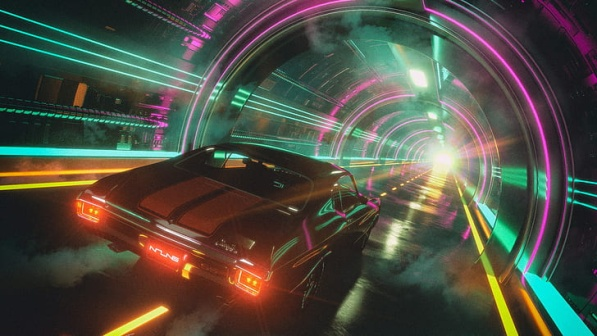Let's say the tunnel connects two different worlds. What could be the differences between these worlds? In this imaginative scenario, the tunnel could connect two vastly different worlds. On one side of the tunnel, we could have a world resembling our present day, with its challenges, limitations, and familiar landscapes. This world might be characterized by regular architecture, conventional vehicles, and a pragmatic way of life. On the other side of the tunnel lies a futuristic world, where technology has advanced beyond our current comprehension. This world could feature towering skyscrapers made of reflective materials, flying cars, and a society powered by renewable energy and artificial intelligence. The stark contrast between these two worlds emphasizes both the advancements we aspire to achieve and the remnants of a simpler, less technologically driven existence. What's a possible short scenario involving the car and the tunnel? The sleek sports car speeds into the tunnel, its engines roaring with power. Neon lights blur past as it accelerates, driven by an urgent need to reach the other side. Moments feel like seconds as the car races towards the bright light at the tunnel's end. Finally, it bursts through the opening into a bustling, futuristic metropolis that glows with activity and innovation. The driver, glancing at the cutting-edge skyline, knows they’ve arrived at their new beginning. Compose a poem inspired by this image. In the tunnel, neon dreams ignite,
A car speeds through the glowing night.
Arches paint the darkness bright,
Guiding wheels towards luminous light.

Black as shadow, the car darts past,
A journey forward, swift and fast.
Red lights gleam, a fleeting cast,
Into future's embrace, it will blast.

Through the tunnel, worlds collide,
From past to future, time's divide.
Speed and progress, side by side,
On this road, hope does abide.  If this image were part of a video game, what kind of game would it be and what would the player's objective be? If this image were part of a video game, it would likely be a high-octane racing game set in a futuristic world. Players would drive advanced, highly customizable sports cars through neon-lit tunnels, sprawling urban landscapes, and other visually stunning environments. The primary objective of the game would be to win races, complete missions, and advance through different levels to unlock new cars, upgrades, and tracks. Additionally, the game could include a narrative element where the player undertakes missions that involve delivering important items or information, escaping from pursuers, and exploring secret futuristic cities. The game's immersive graphics and fast-paced gameplay would keep players engaged as they race towards their goals.  Imagine if the lights in the tunnel were part of a secret code. What could the code be for? If the lights in the tunnel were part of a secret code, they could be relaying critical information hidden in plain sight. The code might be a sequence of colors and patterns that, when decoded, reveal coordinates to a hidden location, access codes to secure facilities, or instructions for a clandestine operation. This secret code could be known only to a select few, such as agents of an underground organization or members of a resistance movement. The protagonist, speeding through the tunnel in their car, could be decoding the lights in real-time, piecing together vital data that leads to uncovering secrets or thwarting a looming threat. 